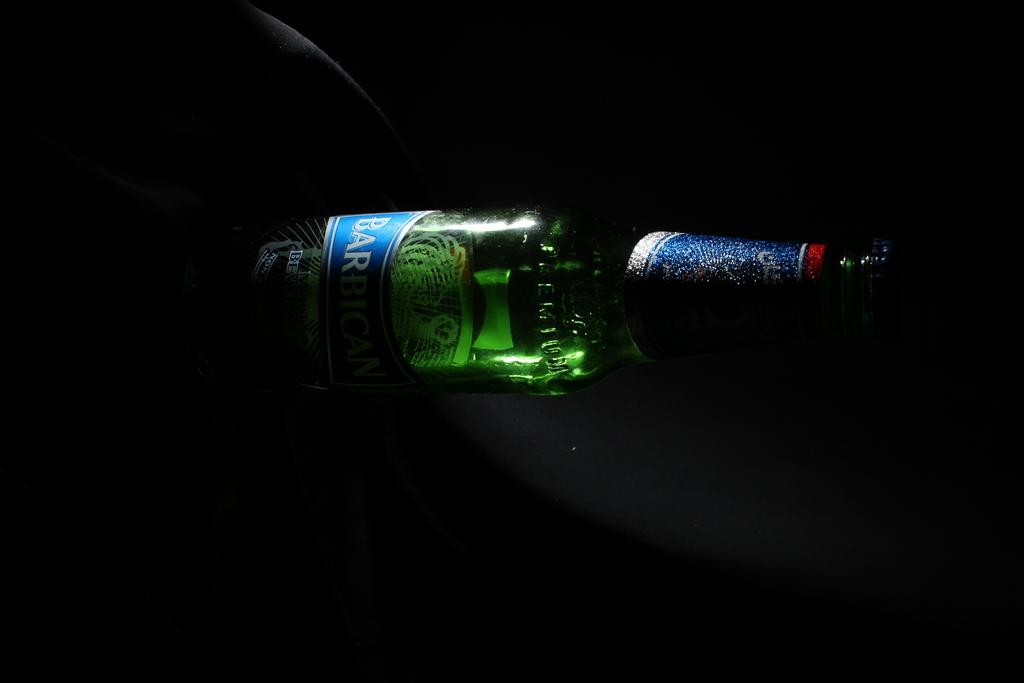Provide a one-sentence caption for the provided image. A Barbig bottle of beer lays sideways on a table. 